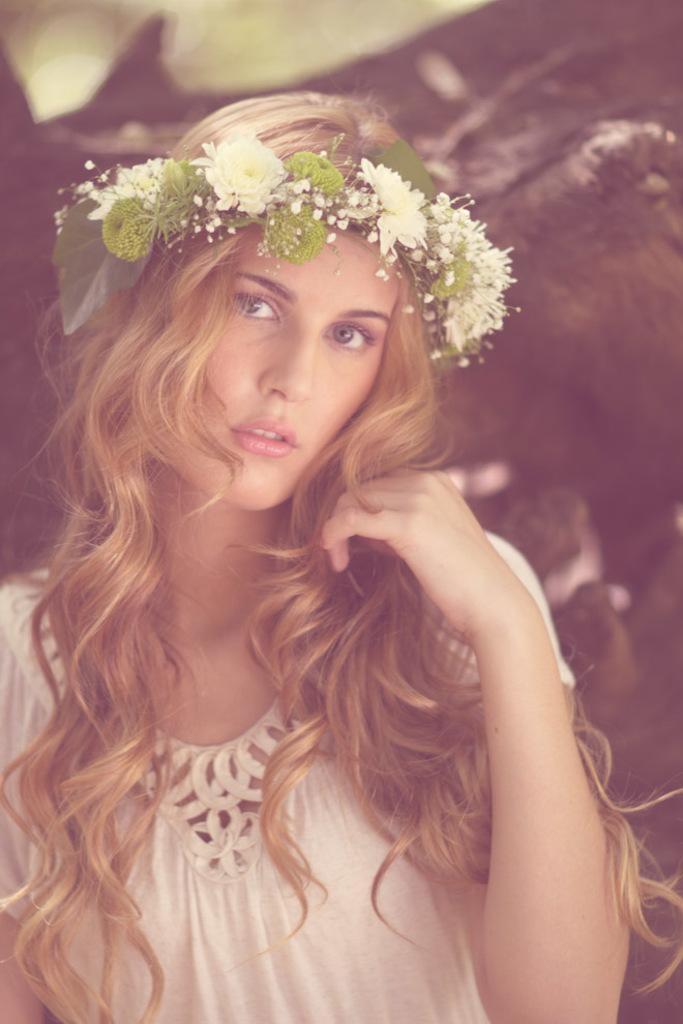In one or two sentences, can you explain what this image depicts? In this image I can see a woman wearing white colored dress and a head band which is cream and green in color. In the background I can see few blurry objects. 